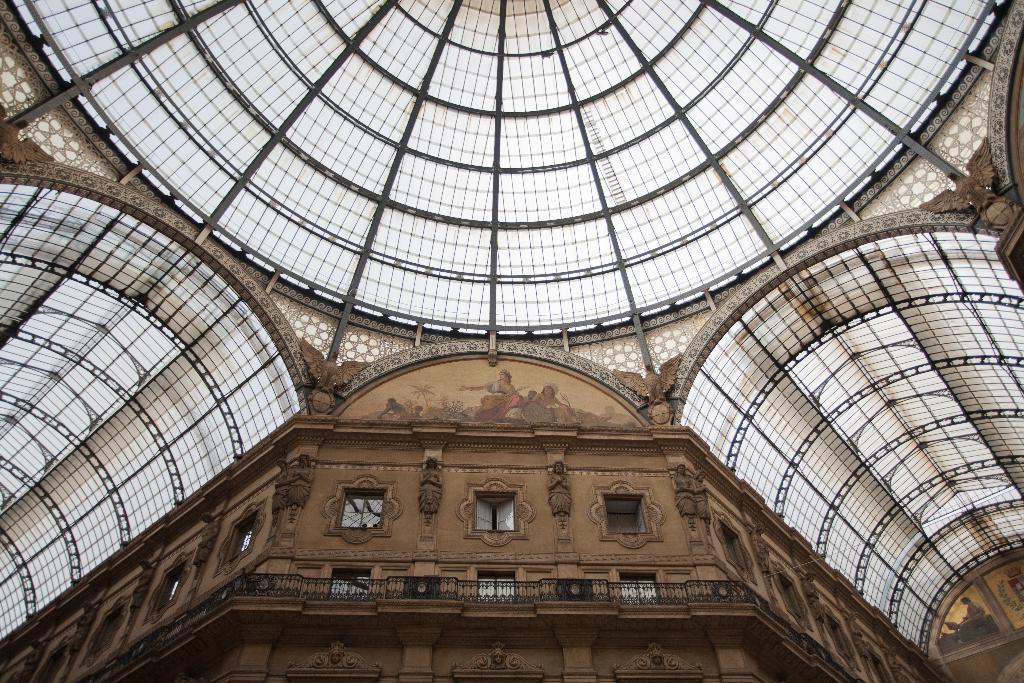Could you give a brief overview of what you see in this image? In this image at the bottom there is a building and some sculptures, and at the top there are some objects and wall. 